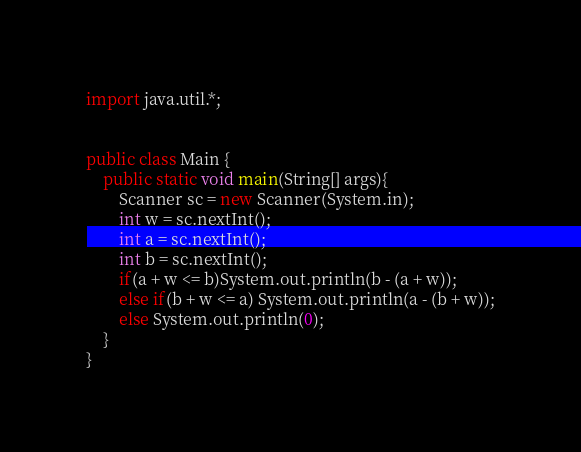Convert code to text. <code><loc_0><loc_0><loc_500><loc_500><_Java_>import java.util.*;


public class Main {
    public static void main(String[] args){
        Scanner sc = new Scanner(System.in);
        int w = sc.nextInt();
        int a = sc.nextInt();
        int b = sc.nextInt();
        if(a + w <= b)System.out.println(b - (a + w));
        else if(b + w <= a) System.out.println(a - (b + w));
        else System.out.println(0);
    }
}
</code> 